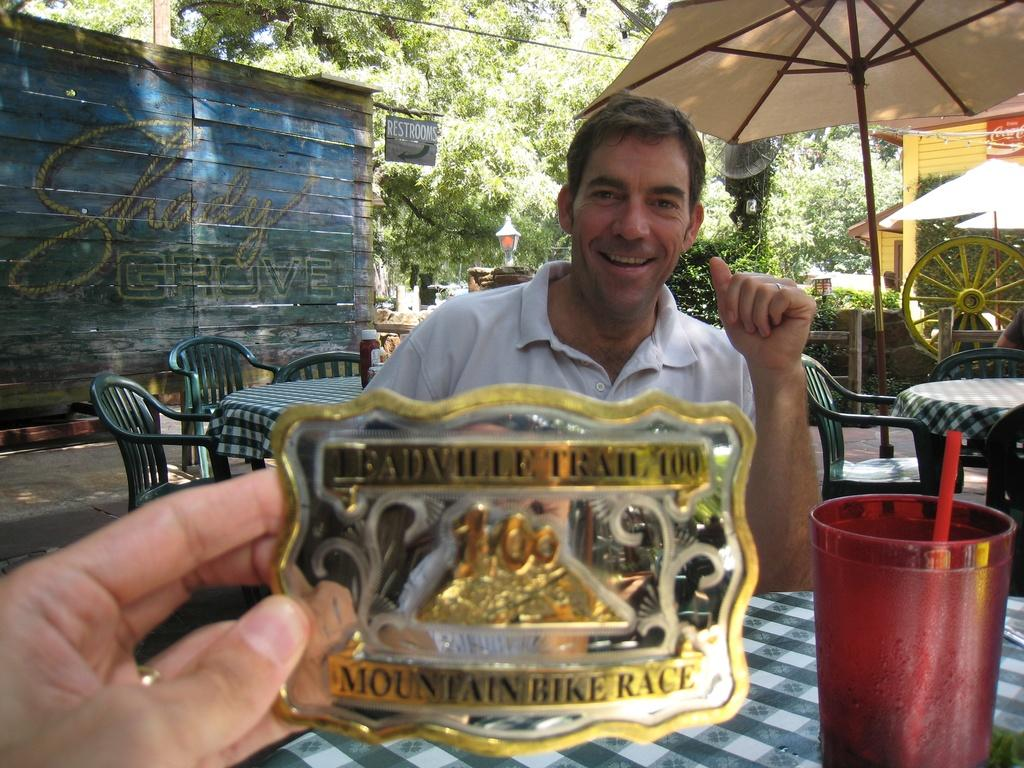What is the main subject of the image? There is a man in the image. What is the man doing in the image? The man is sitting and smiling. What is located near the man in the image? There is a table in the image. What is on the table in the image? There is a glass and other objects on the table. What can be seen in the background of the image? There is a wall and trees in the image. How many ladybugs are crawling on the man's shoulder in the image? There are no ladybugs present in the image. What type of bird is perched on the tree branch in the image? There is no bird visible in the image; only trees are present in the background. 